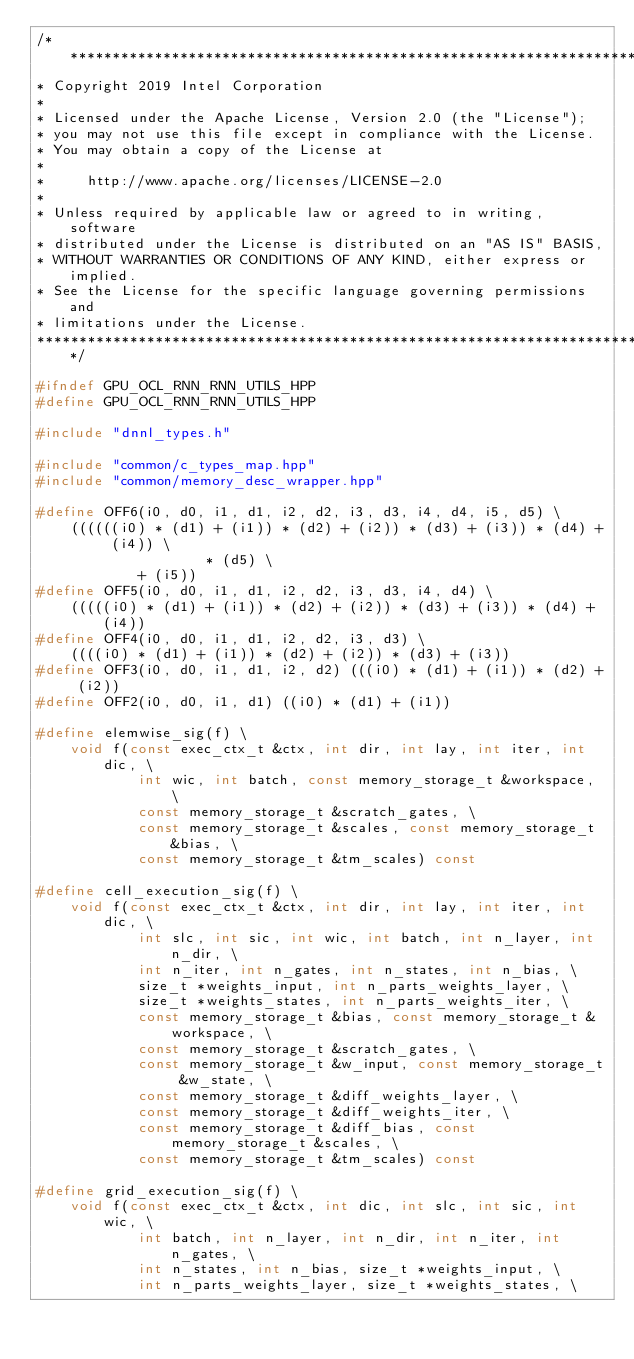<code> <loc_0><loc_0><loc_500><loc_500><_C++_>/*******************************************************************************
* Copyright 2019 Intel Corporation
*
* Licensed under the Apache License, Version 2.0 (the "License");
* you may not use this file except in compliance with the License.
* You may obtain a copy of the License at
*
*     http://www.apache.org/licenses/LICENSE-2.0
*
* Unless required by applicable law or agreed to in writing, software
* distributed under the License is distributed on an "AS IS" BASIS,
* WITHOUT WARRANTIES OR CONDITIONS OF ANY KIND, either express or implied.
* See the License for the specific language governing permissions and
* limitations under the License.
*******************************************************************************/

#ifndef GPU_OCL_RNN_RNN_UTILS_HPP
#define GPU_OCL_RNN_RNN_UTILS_HPP

#include "dnnl_types.h"

#include "common/c_types_map.hpp"
#include "common/memory_desc_wrapper.hpp"

#define OFF6(i0, d0, i1, d1, i2, d2, i3, d3, i4, d4, i5, d5) \
    ((((((i0) * (d1) + (i1)) * (d2) + (i2)) * (d3) + (i3)) * (d4) + (i4)) \
                    * (d5) \
            + (i5))
#define OFF5(i0, d0, i1, d1, i2, d2, i3, d3, i4, d4) \
    (((((i0) * (d1) + (i1)) * (d2) + (i2)) * (d3) + (i3)) * (d4) + (i4))
#define OFF4(i0, d0, i1, d1, i2, d2, i3, d3) \
    ((((i0) * (d1) + (i1)) * (d2) + (i2)) * (d3) + (i3))
#define OFF3(i0, d0, i1, d1, i2, d2) (((i0) * (d1) + (i1)) * (d2) + (i2))
#define OFF2(i0, d0, i1, d1) ((i0) * (d1) + (i1))

#define elemwise_sig(f) \
    void f(const exec_ctx_t &ctx, int dir, int lay, int iter, int dic, \
            int wic, int batch, const memory_storage_t &workspace, \
            const memory_storage_t &scratch_gates, \
            const memory_storage_t &scales, const memory_storage_t &bias, \
            const memory_storage_t &tm_scales) const

#define cell_execution_sig(f) \
    void f(const exec_ctx_t &ctx, int dir, int lay, int iter, int dic, \
            int slc, int sic, int wic, int batch, int n_layer, int n_dir, \
            int n_iter, int n_gates, int n_states, int n_bias, \
            size_t *weights_input, int n_parts_weights_layer, \
            size_t *weights_states, int n_parts_weights_iter, \
            const memory_storage_t &bias, const memory_storage_t &workspace, \
            const memory_storage_t &scratch_gates, \
            const memory_storage_t &w_input, const memory_storage_t &w_state, \
            const memory_storage_t &diff_weights_layer, \
            const memory_storage_t &diff_weights_iter, \
            const memory_storage_t &diff_bias, const memory_storage_t &scales, \
            const memory_storage_t &tm_scales) const

#define grid_execution_sig(f) \
    void f(const exec_ctx_t &ctx, int dic, int slc, int sic, int wic, \
            int batch, int n_layer, int n_dir, int n_iter, int n_gates, \
            int n_states, int n_bias, size_t *weights_input, \
            int n_parts_weights_layer, size_t *weights_states, \</code> 